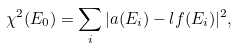Convert formula to latex. <formula><loc_0><loc_0><loc_500><loc_500>\chi ^ { 2 } ( E _ { 0 } ) = \sum _ { i } | a ( E _ { i } ) - l f ( E _ { i } ) | ^ { 2 } ,</formula> 